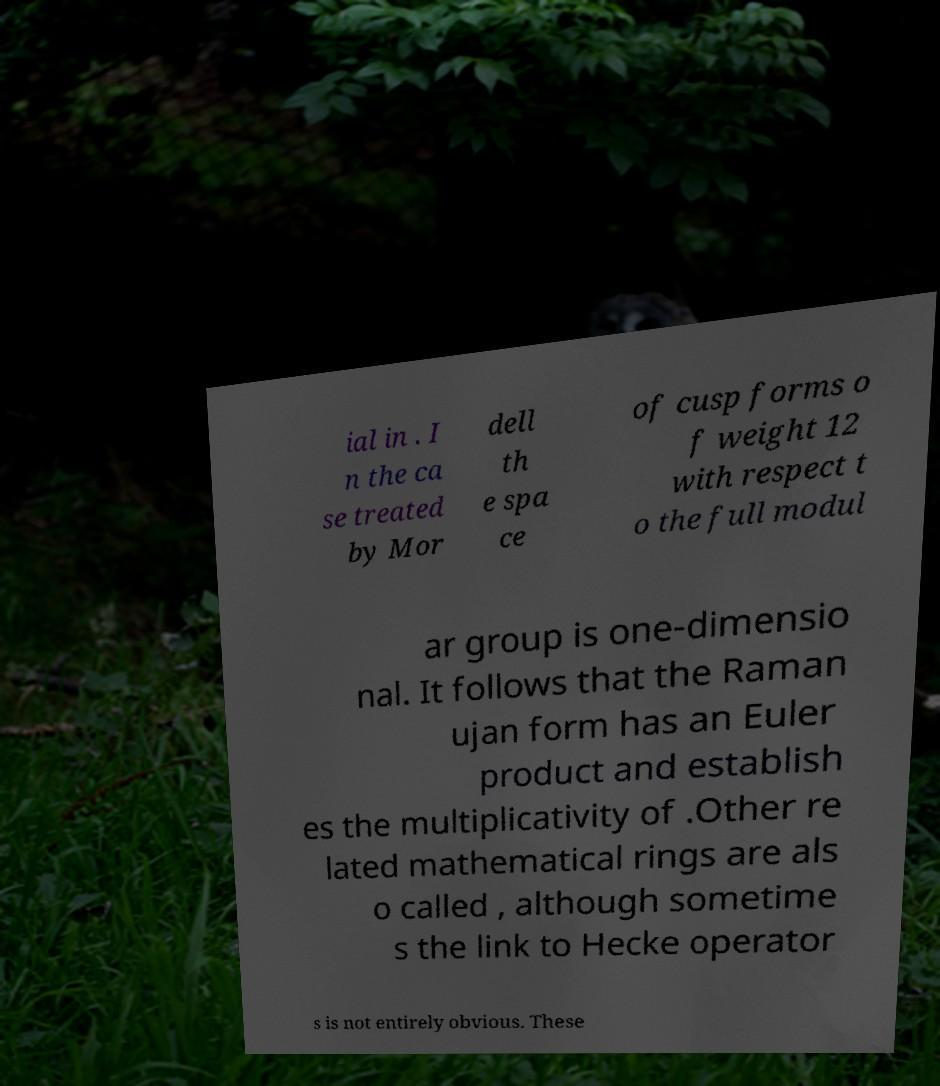There's text embedded in this image that I need extracted. Can you transcribe it verbatim? ial in . I n the ca se treated by Mor dell th e spa ce of cusp forms o f weight 12 with respect t o the full modul ar group is one-dimensio nal. It follows that the Raman ujan form has an Euler product and establish es the multiplicativity of .Other re lated mathematical rings are als o called , although sometime s the link to Hecke operator s is not entirely obvious. These 